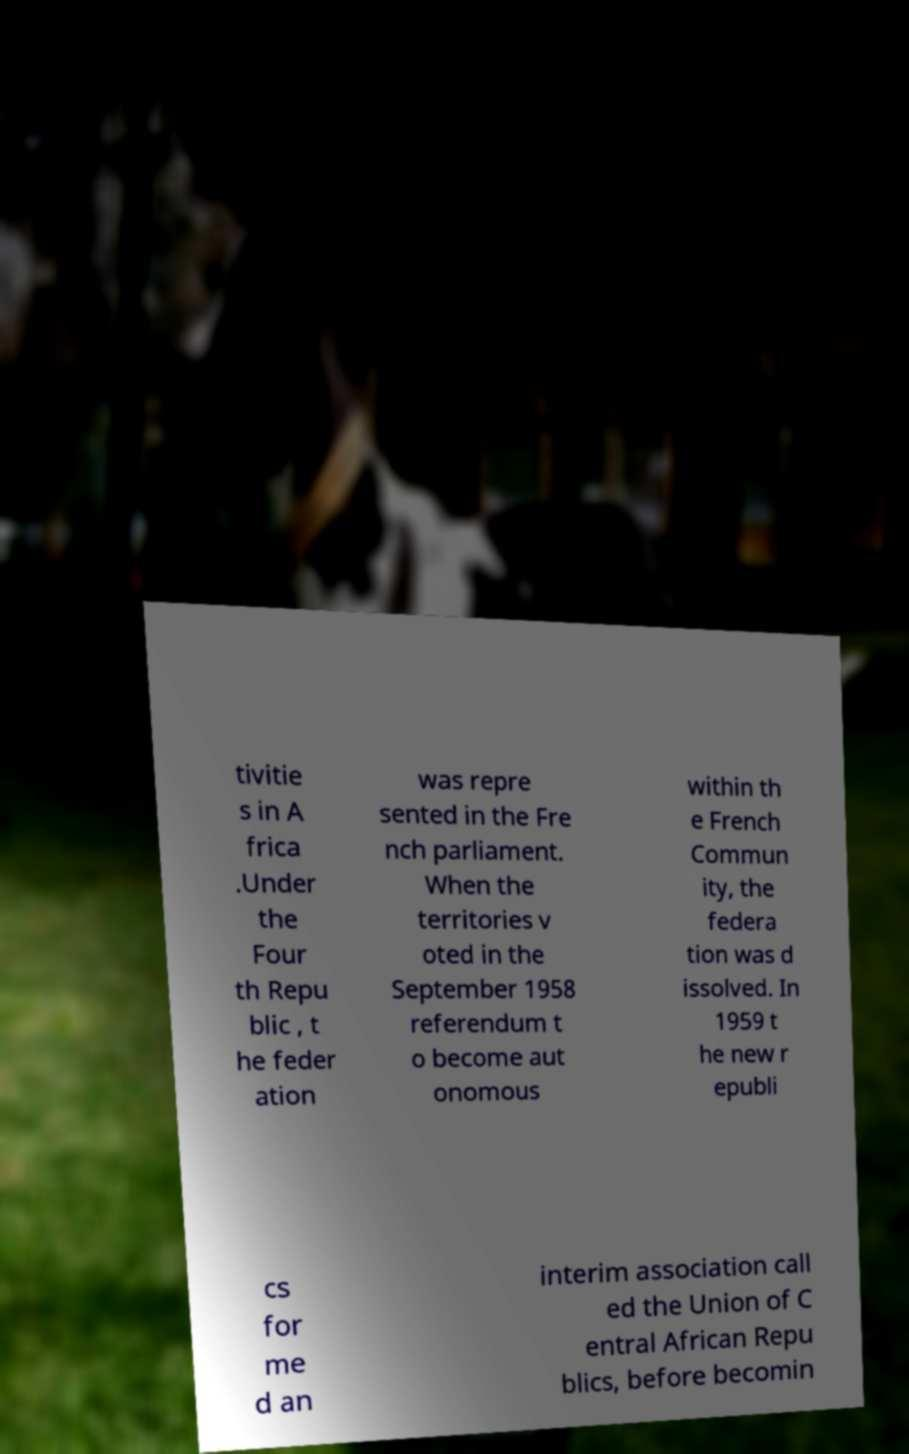For documentation purposes, I need the text within this image transcribed. Could you provide that? tivitie s in A frica .Under the Four th Repu blic , t he feder ation was repre sented in the Fre nch parliament. When the territories v oted in the September 1958 referendum t o become aut onomous within th e French Commun ity, the federa tion was d issolved. In 1959 t he new r epubli cs for me d an interim association call ed the Union of C entral African Repu blics, before becomin 